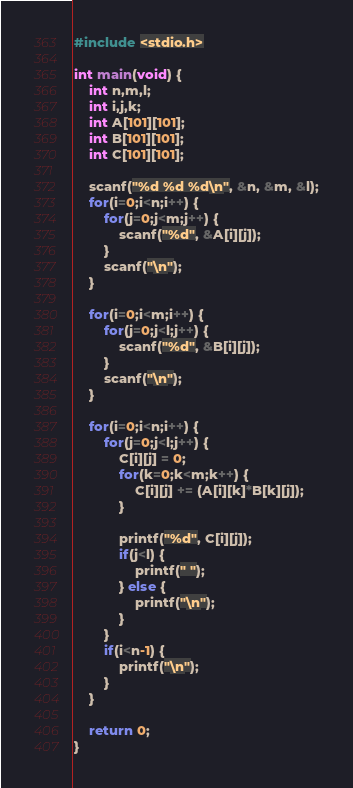Convert code to text. <code><loc_0><loc_0><loc_500><loc_500><_C_>#include <stdio.h>

int main(void) {
	int n,m,l;
	int i,j,k;
	int A[101][101];
	int B[101][101];
	int C[101][101];
	
	scanf("%d %d %d\n", &n, &m, &l);
	for(i=0;i<n;i++) {
		for(j=0;j<m;j++) {
			scanf("%d", &A[i][j]);
		}
		scanf("\n");
	}

	for(i=0;i<m;i++) {
		for(j=0;j<l;j++) {
			scanf("%d", &B[i][j]);
		}
		scanf("\n");
	}
	
	for(i=0;i<n;i++) {
		for(j=0;j<l;j++) {
			C[i][j] = 0;
			for(k=0;k<m;k++) {
				C[i][j] += (A[i][k]*B[k][j]);
			}
			
			printf("%d", C[i][j]);
			if(j<l) {
				printf(" ");
			} else {
				printf("\n");
			}
		}
		if(i<n-1) {
			printf("\n");
		}
	}
	
	return 0;
}</code> 